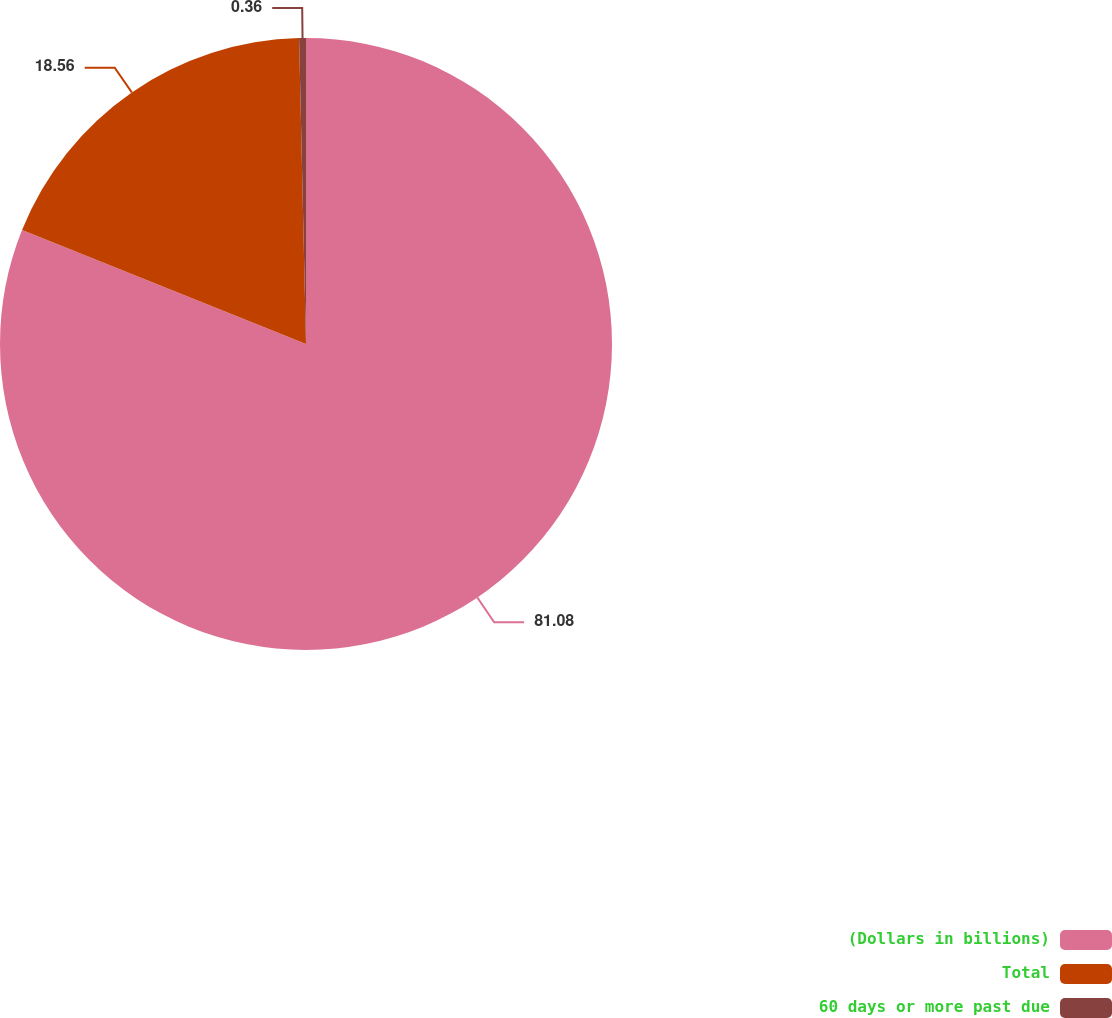<chart> <loc_0><loc_0><loc_500><loc_500><pie_chart><fcel>(Dollars in billions)<fcel>Total<fcel>60 days or more past due<nl><fcel>81.08%<fcel>18.56%<fcel>0.36%<nl></chart> 